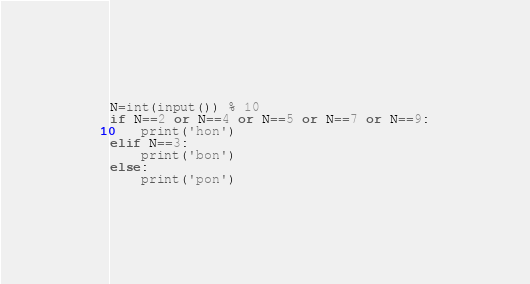Convert code to text. <code><loc_0><loc_0><loc_500><loc_500><_Python_>N=int(input()) % 10
if N==2 or N==4 or N==5 or N==7 or N==9:
	print('hon')
elif N==3:
	print('bon')
else:
	print('pon')
</code> 